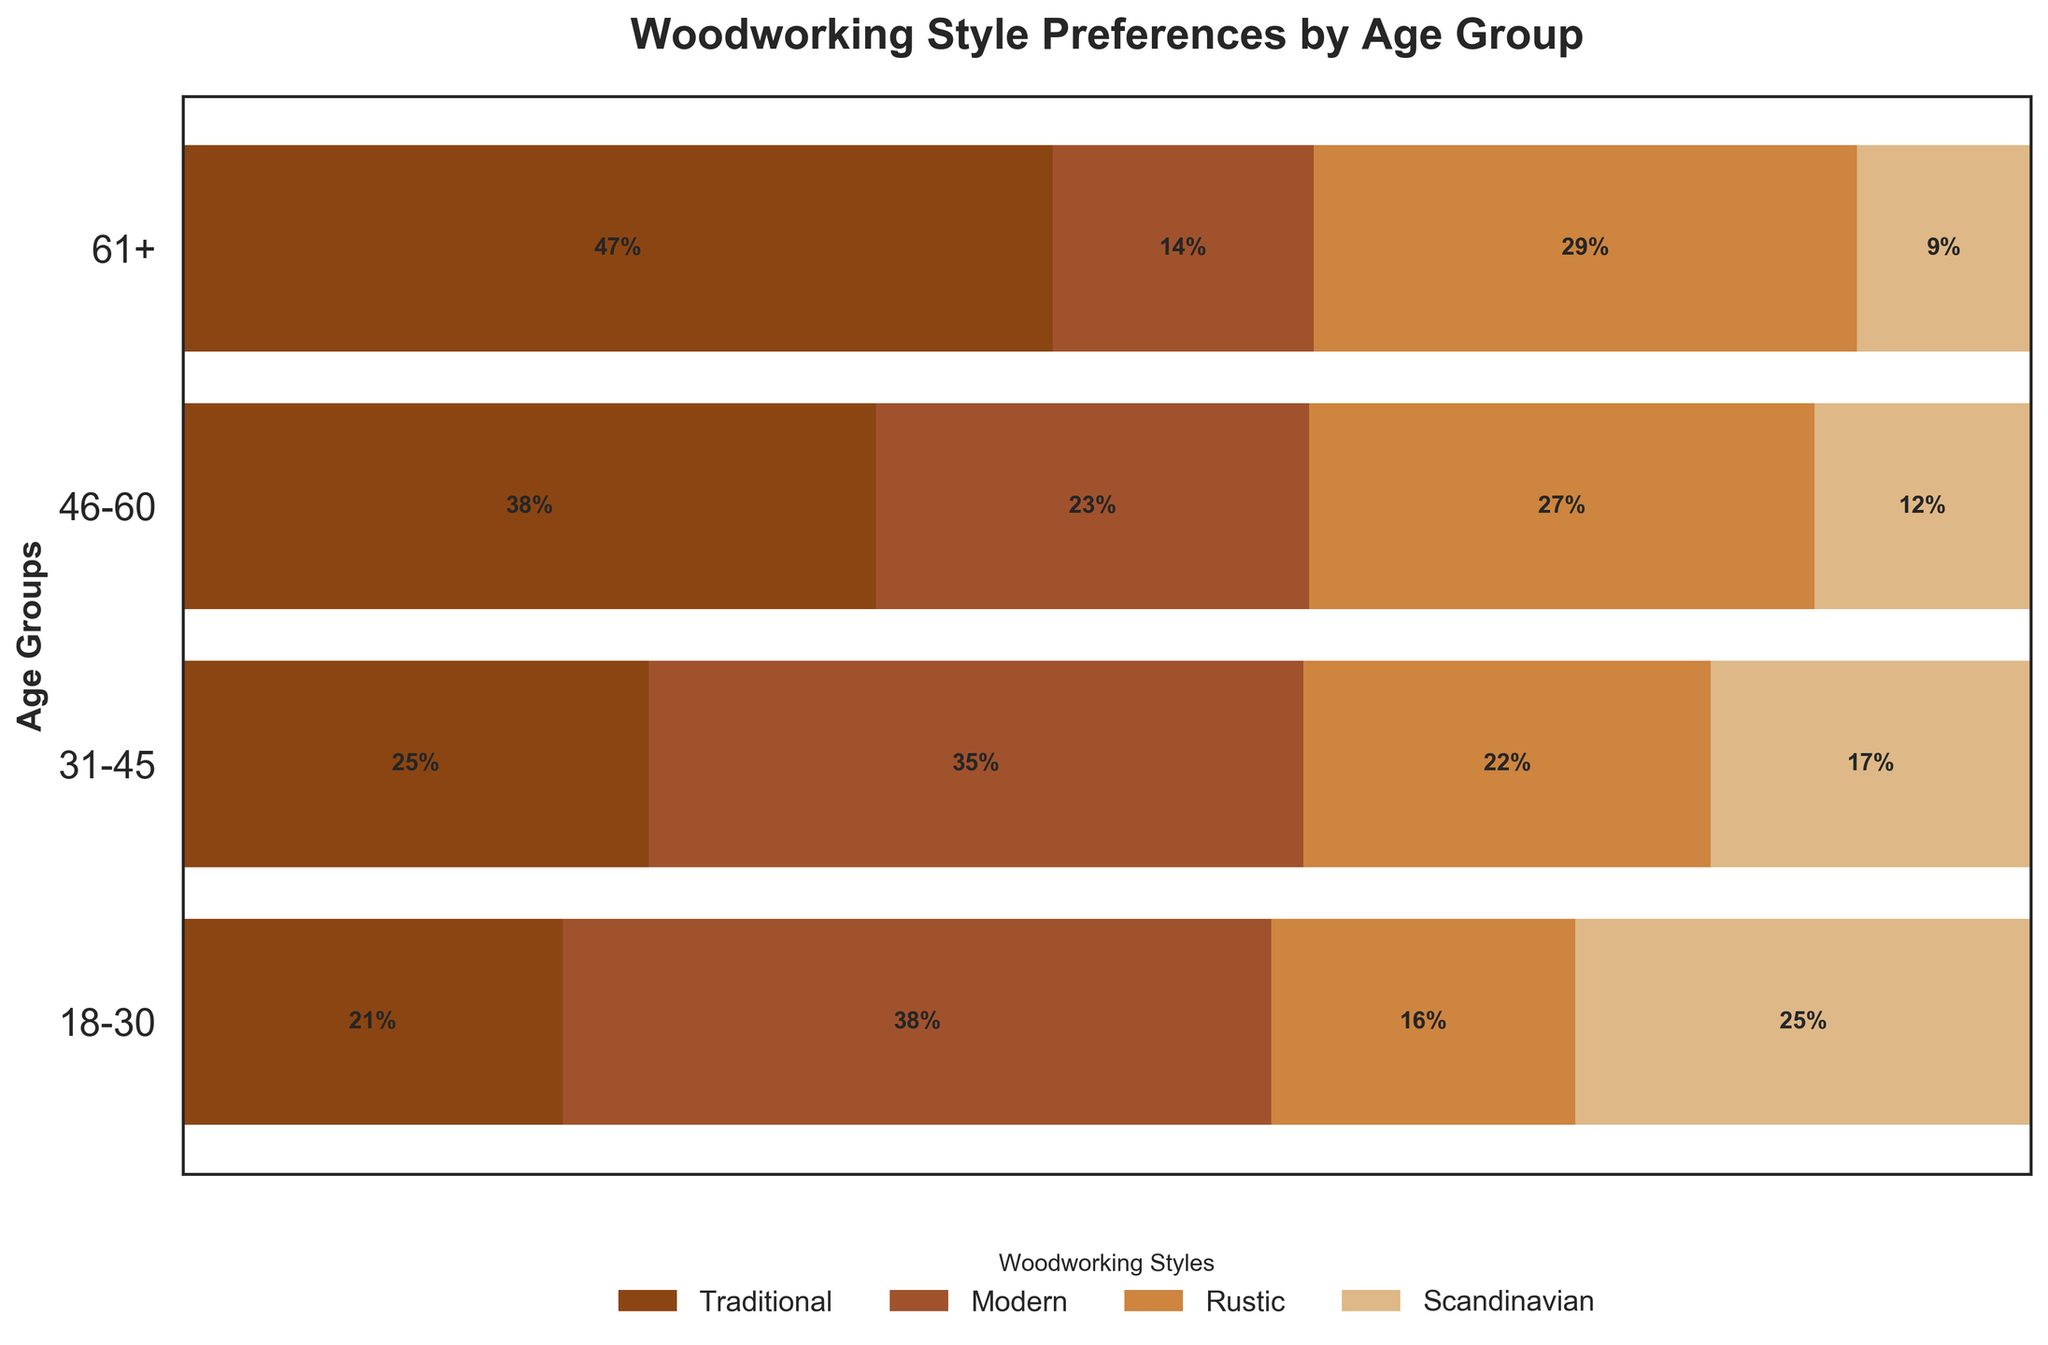What is the title of the figure? The title is usually found at the top of the chart, and it is: "Woodworking Style Preferences by Age Group".
Answer: Woodworking Style Preferences by Age Group Which age group has the highest percentage preference for Traditional woodworking? To find this, look at each age group’s Traditional segment and identify which one is the longest. The age group 46-60 has the largest Traditional segment.
Answer: 46-60 What percentage of the 18-30 age group prefers Modern woodworking? Locate the Modern segment within the 18-30 bar and read the percentage label within that segment. The percentage is 56%.
Answer: 56% Is Rustic woodworking more popular among the 31-45 or 61+ age groups? Compare the lengths of the Rustic segments for these two age groups. The Rustic segment is larger for the 31-45 age group than for the 61+ age group.
Answer: 31-45 Which age group shows the least interest in Scandinavian woodworking? Identify the smallest Scandinavian segment among all age groups. The 61+ age group's Scandinavian segment is the smallest.
Answer: 61+ What is the color used to represent Modern woodworking in the plot? The colors in the legend match the segments in the bars. The Modern woodworking segment is represented by the second color in the legend, which is a mid-tone brown.
Answer: Mid-tone brown How does the preference for Rustic woodworking change across the age groups? Observe the Rustic segments' lengths from the youngest to the oldest age groups. The proportions start lower in the 18-30 group, increase in the 31-45 group, peak in the 46-60 group, and then decrease in the 61+ group.
Answer: Increases, peaks, then decreases Which age group has the most evenly distributed preferences among the four woodworking styles? Look for the age group whose bars have relatively similar widths for all segments. The 31-45 age group shows the most even distribution among the four styles.
Answer: 31-45 How much larger is the preference for Modern woodworking in the 18-30 age group compared to the 61+ age group? Subtract the percentage of the 61+ Modern segment from the percentage of the 18-30 Modern segment. The difference is 56% - 12% = 44%.
Answer: 44% Does the preference for Traditional woodworking increase or decrease with age? Observe the trend in the Traditional segments from youngest to oldest. The preference generally increases from the 18-30 group to the 46-60 group and then slightly decreases for the 61+ group.
Answer: Increases then slightly decreases 